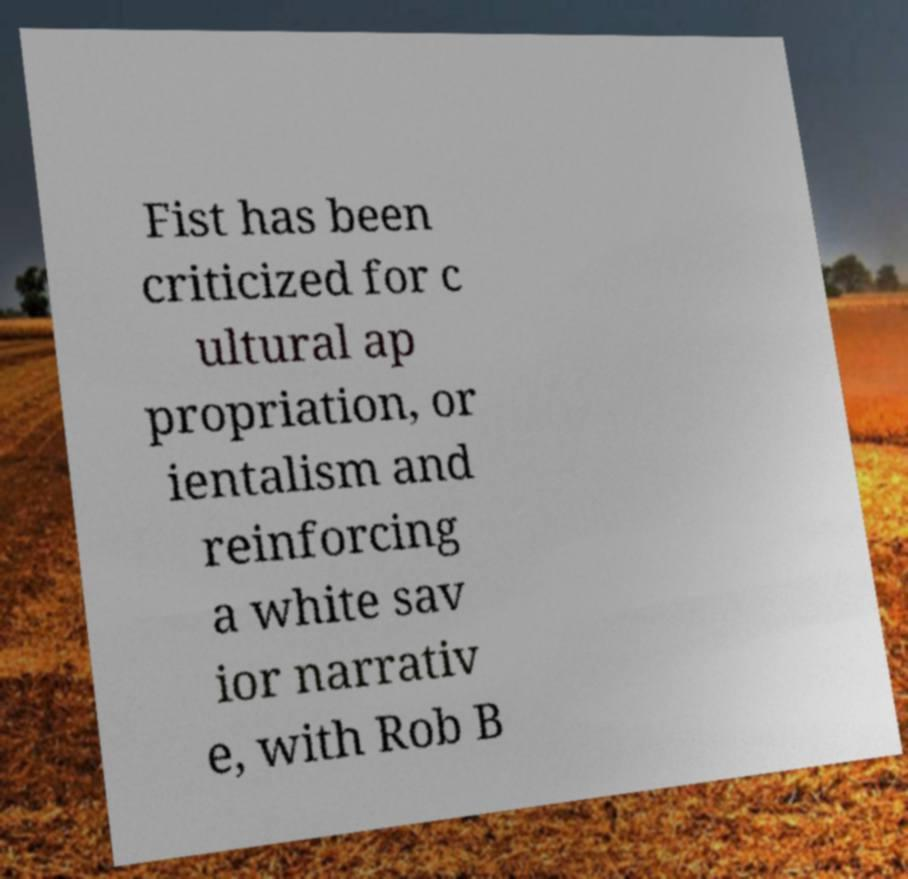What messages or text are displayed in this image? I need them in a readable, typed format. Fist has been criticized for c ultural ap propriation, or ientalism and reinforcing a white sav ior narrativ e, with Rob B 